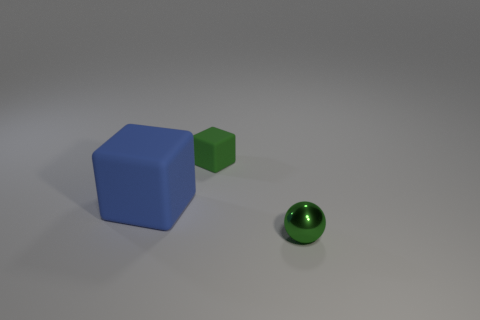What is the material of the green object that is on the left side of the small green thing in front of the tiny green matte thing?
Your answer should be very brief. Rubber. Are there any other small cubes that have the same material as the blue block?
Your answer should be compact. Yes. What is the material of the other thing that is the same size as the green matte object?
Keep it short and to the point. Metal. What size is the green object to the left of the tiny green object that is in front of the small object behind the small metallic sphere?
Make the answer very short. Small. Are there any tiny green spheres behind the tiny object on the right side of the tiny cube?
Provide a short and direct response. No. Do the big matte object and the tiny green object behind the tiny green shiny ball have the same shape?
Your response must be concise. Yes. What color is the small thing that is left of the tiny green shiny ball?
Your response must be concise. Green. There is a matte cube behind the matte object to the left of the tiny rubber block; what is its size?
Provide a succinct answer. Small. Does the matte thing that is to the right of the big blue object have the same shape as the metal object?
Your answer should be very brief. No. What material is the small object that is the same shape as the large thing?
Offer a very short reply. Rubber. 